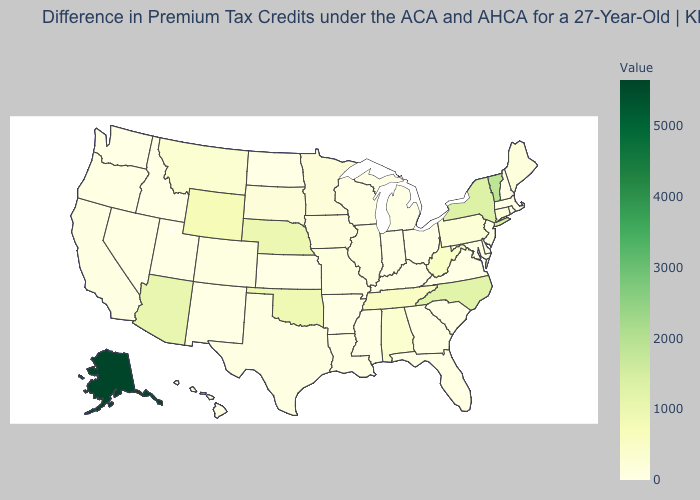Does New Mexico have the lowest value in the West?
Give a very brief answer. Yes. Is the legend a continuous bar?
Quick response, please. Yes. Which states have the lowest value in the USA?
Be succinct. Arkansas, Delaware, Hawaii, Idaho, Indiana, Kansas, Kentucky, Maryland, Massachusetts, Michigan, Mississippi, New Hampshire, New Jersey, New Mexico, North Dakota, Ohio, Rhode Island, South Carolina, Utah, Virginia, Washington. Does New Hampshire have the lowest value in the USA?
Keep it brief. Yes. Is the legend a continuous bar?
Keep it brief. Yes. Is the legend a continuous bar?
Short answer required. Yes. Does Ohio have the lowest value in the MidWest?
Answer briefly. Yes. 